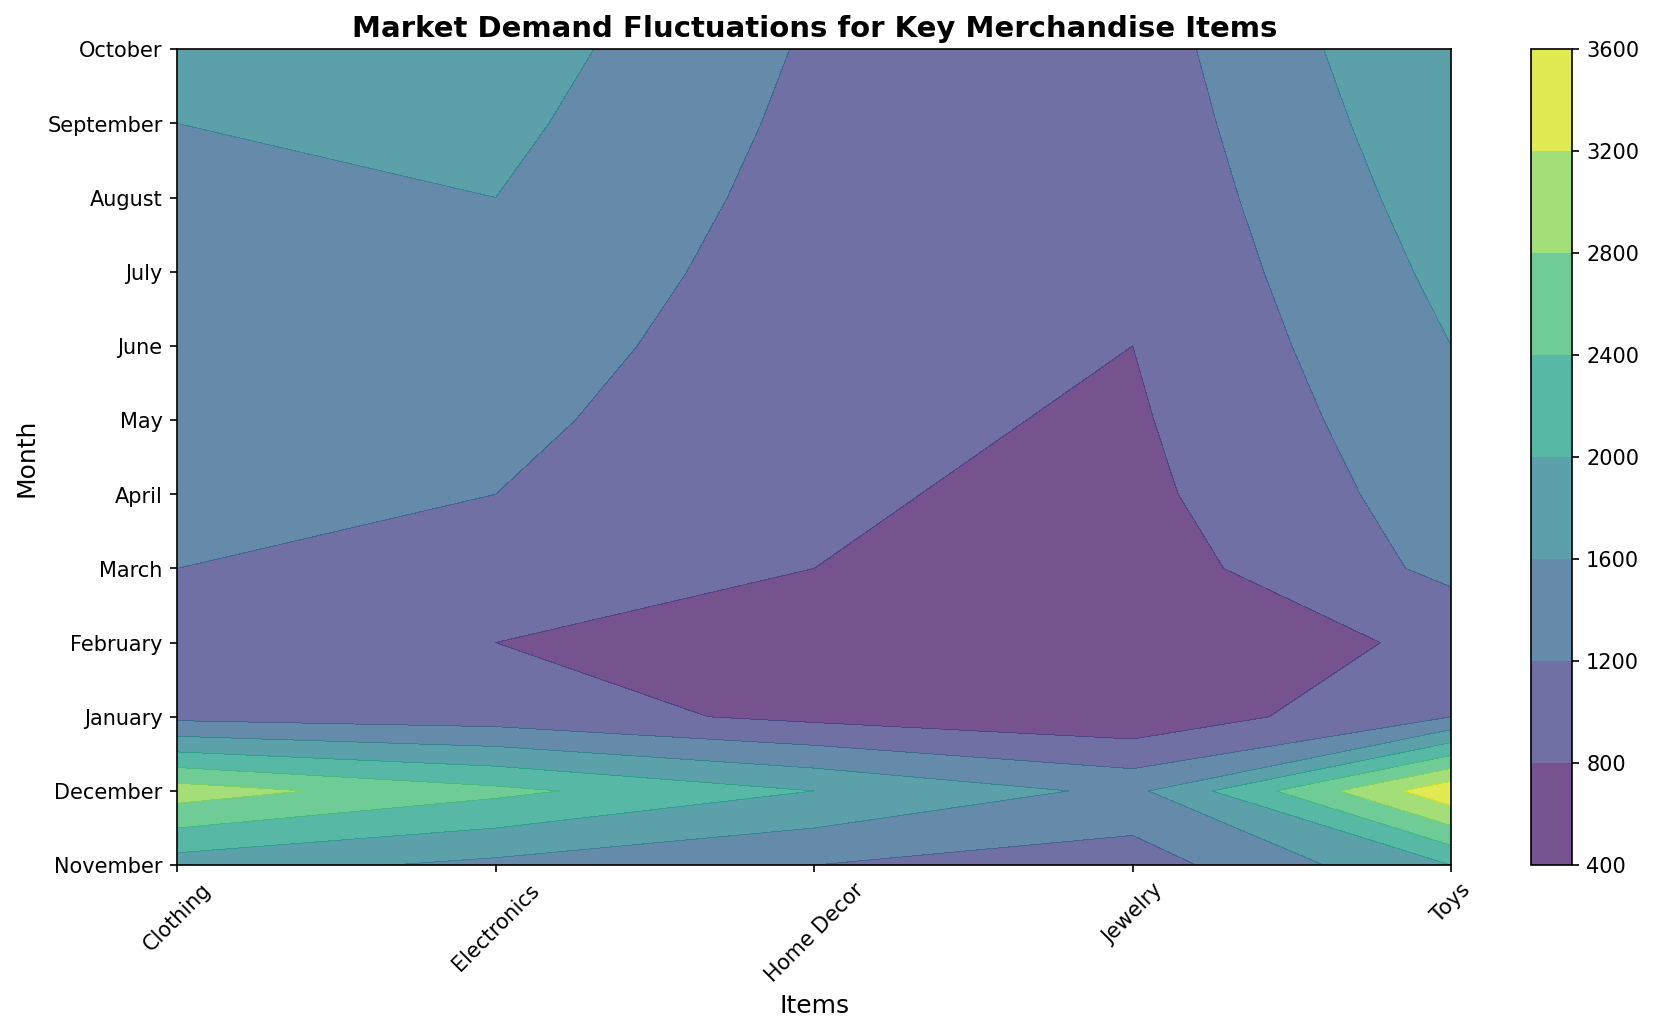Which month has the highest demand for Toys? By observing the color intensity in the contour plot, the month with the highest demand for Toys corresponds to the darkest region, which is in December.
Answer: December What is the total sales of Electronics in the first quarter? Sum the sales of Electronics in January, February, and March. From the plot, Electronics sold 1000 units in January, 800 in February, and 1100 in March. 1000 + 800 + 1100 = 2900
Answer: 2900 Compare the sales of Jewelry in November and April. Which month has higher sales? Observing the contour plot, the color intensity for Jewelry in November and April indicates higher sales. Jewelry in November has higher demand with 1000 units compared to 700 units in April.
Answer: November What is the average sales of Home Decor across all the months? Sum the sales values of Home Decor from all the months and divide by the number of months. Home Decor sales: 1200 + 2000 + 700 + 600 + 800 + 850 + 900 + 950 + 1000 + 1050 + 1100 + 1150 = 13300. There are 12 months, so 13300 / 12 = 1108.33
Answer: 1108.33 Which merchandise item has the steadiest demand throughout the year? By observing the contour plot, the merchandise with the most consistent color intensity throughout the year indicates a steadier demand. Clothing's gradient is relatively uniform, suggesting the steadiest demand.
Answer: Clothing In which month did Electronics witness a significant drop in sales compared to the previous month? Look for months where the color for Electronics changes significantly from dark to light. From December to January, Electronics sales drop from 2500 to 1000 units, a significant decrease.
Answer: January Are sales for Electronics higher in the summer (June, July, August) or the fall (September, October, November)? Sum the sales of Electronics in June, July, and August, and compare them with the sum of September, October, and November. Summer: 1400 + 1500 + 1600 = 4500; Fall: 1700 + 1800 + 1500 = 5000. Sales for Electronics are higher in the fall.
Answer: Fall What is the difference in sales between the highest and lowest month for Home Decor? Identify the highest and lowest sales for Home Decor by the color intensity. The highest color intensity is in December with 2000 units, the lowest in February with 600 units. Difference = 2000 - 600 = 1400
Answer: 1400 During which month does Jewelry experience the least demand? Observe the contour plot for months with the lightest color for Jewelry. February has the least demand for Jewelry with 450 units.
Answer: February Which item shows the largest increase in sales from February to March? Compare the color intensity changes for each item from February to March. Toys increase from 900 to 1300 units, the largest increase among all items.
Answer: Toys 